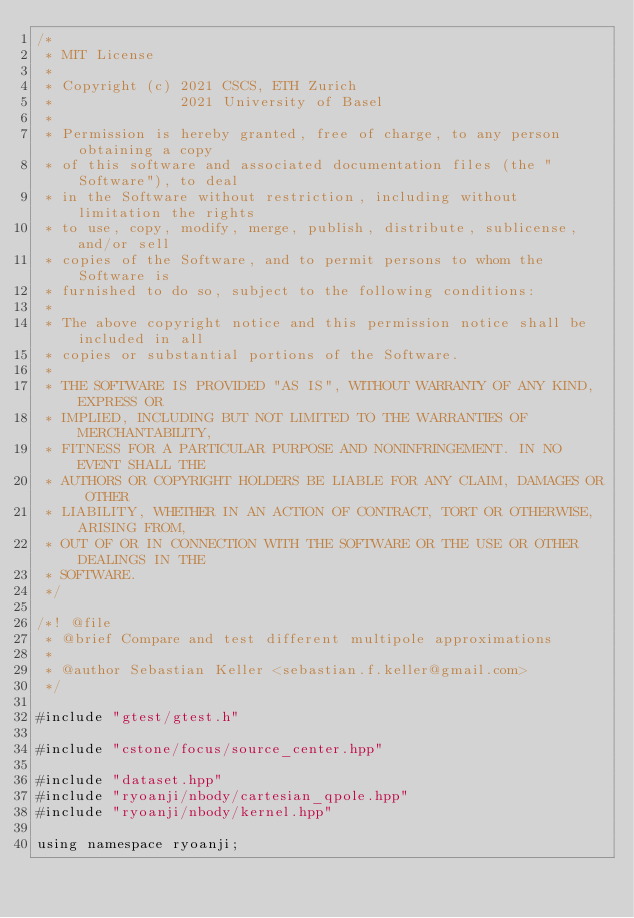<code> <loc_0><loc_0><loc_500><loc_500><_Cuda_>/*
 * MIT License
 *
 * Copyright (c) 2021 CSCS, ETH Zurich
 *               2021 University of Basel
 *
 * Permission is hereby granted, free of charge, to any person obtaining a copy
 * of this software and associated documentation files (the "Software"), to deal
 * in the Software without restriction, including without limitation the rights
 * to use, copy, modify, merge, publish, distribute, sublicense, and/or sell
 * copies of the Software, and to permit persons to whom the Software is
 * furnished to do so, subject to the following conditions:
 *
 * The above copyright notice and this permission notice shall be included in all
 * copies or substantial portions of the Software.
 *
 * THE SOFTWARE IS PROVIDED "AS IS", WITHOUT WARRANTY OF ANY KIND, EXPRESS OR
 * IMPLIED, INCLUDING BUT NOT LIMITED TO THE WARRANTIES OF MERCHANTABILITY,
 * FITNESS FOR A PARTICULAR PURPOSE AND NONINFRINGEMENT. IN NO EVENT SHALL THE
 * AUTHORS OR COPYRIGHT HOLDERS BE LIABLE FOR ANY CLAIM, DAMAGES OR OTHER
 * LIABILITY, WHETHER IN AN ACTION OF CONTRACT, TORT OR OTHERWISE, ARISING FROM,
 * OUT OF OR IN CONNECTION WITH THE SOFTWARE OR THE USE OR OTHER DEALINGS IN THE
 * SOFTWARE.
 */

/*! @file
 * @brief Compare and test different multipole approximations
 *
 * @author Sebastian Keller <sebastian.f.keller@gmail.com>
 */

#include "gtest/gtest.h"

#include "cstone/focus/source_center.hpp"

#include "dataset.hpp"
#include "ryoanji/nbody/cartesian_qpole.hpp"
#include "ryoanji/nbody/kernel.hpp"

using namespace ryoanji;
</code> 